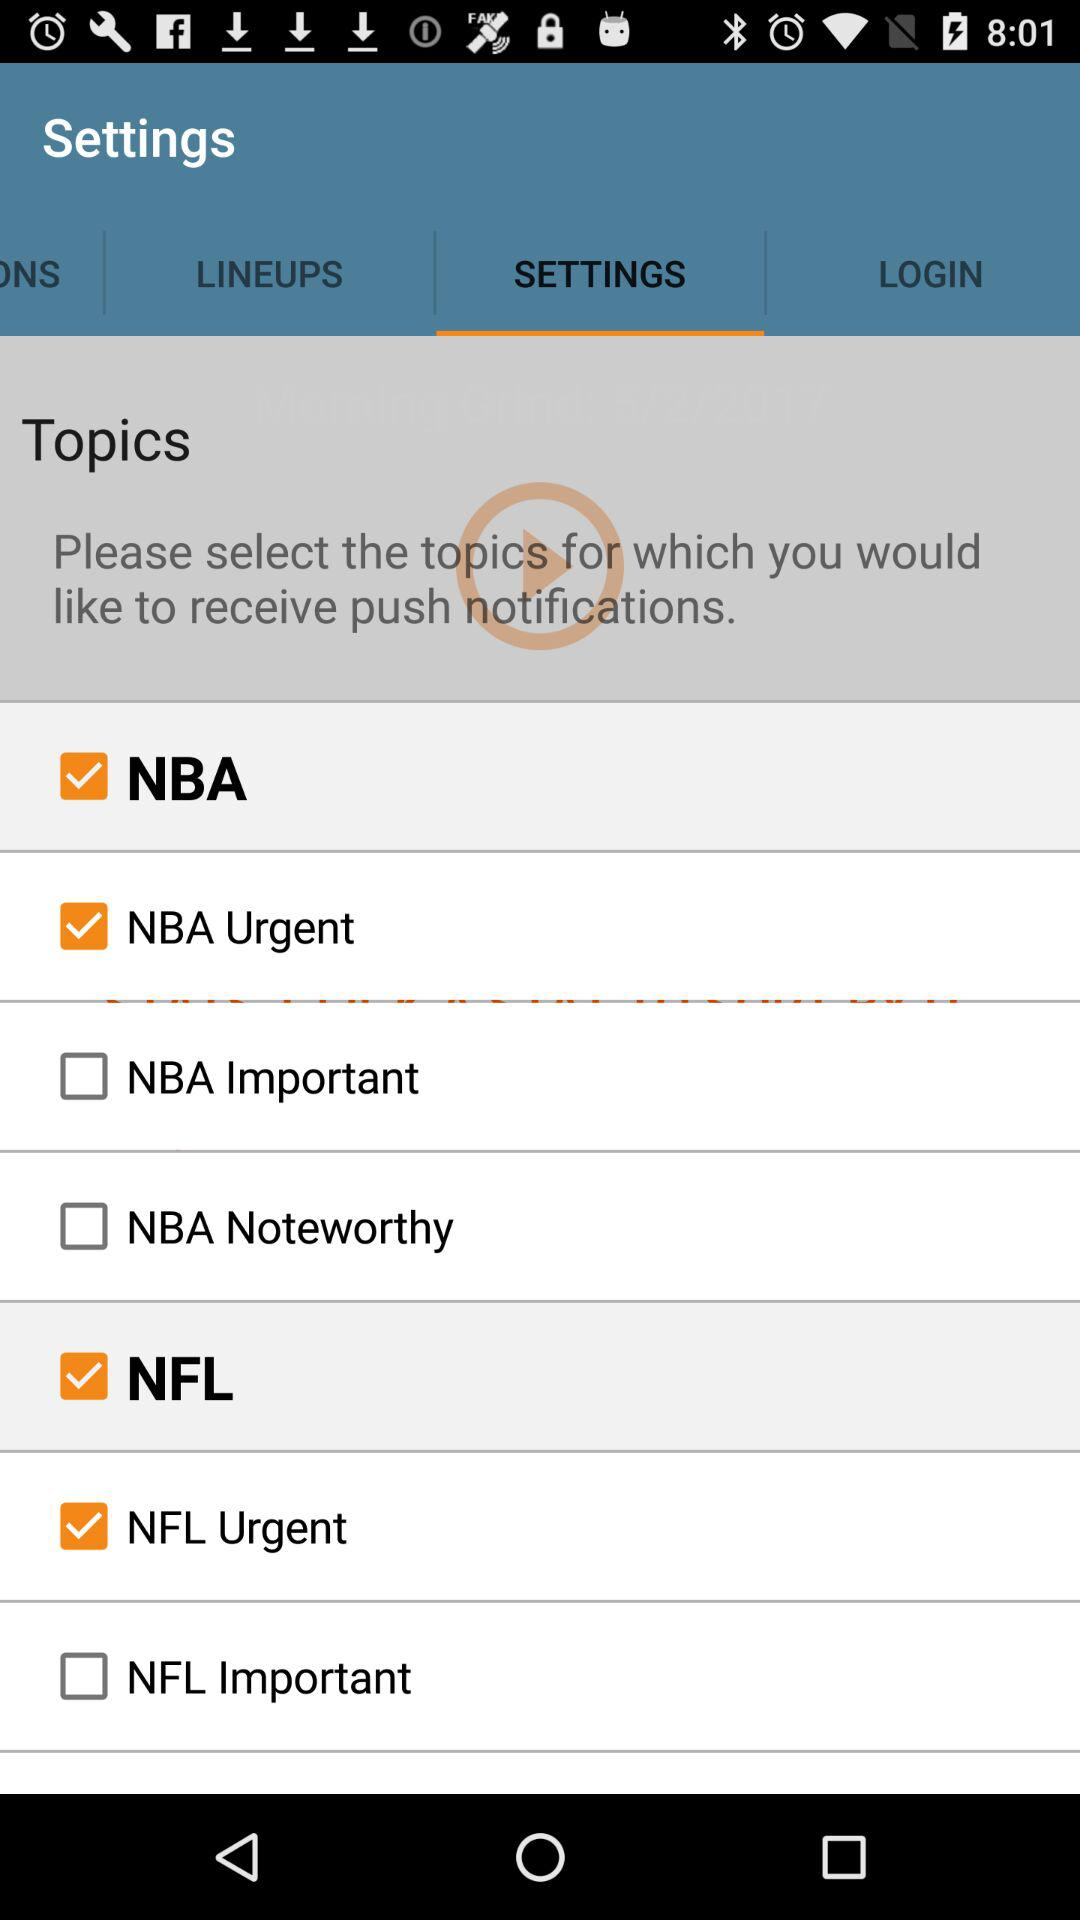What categories are available in the NBA? The categories are "NBA Urgent", "NBA Important", and "NBA Noteworthy". 